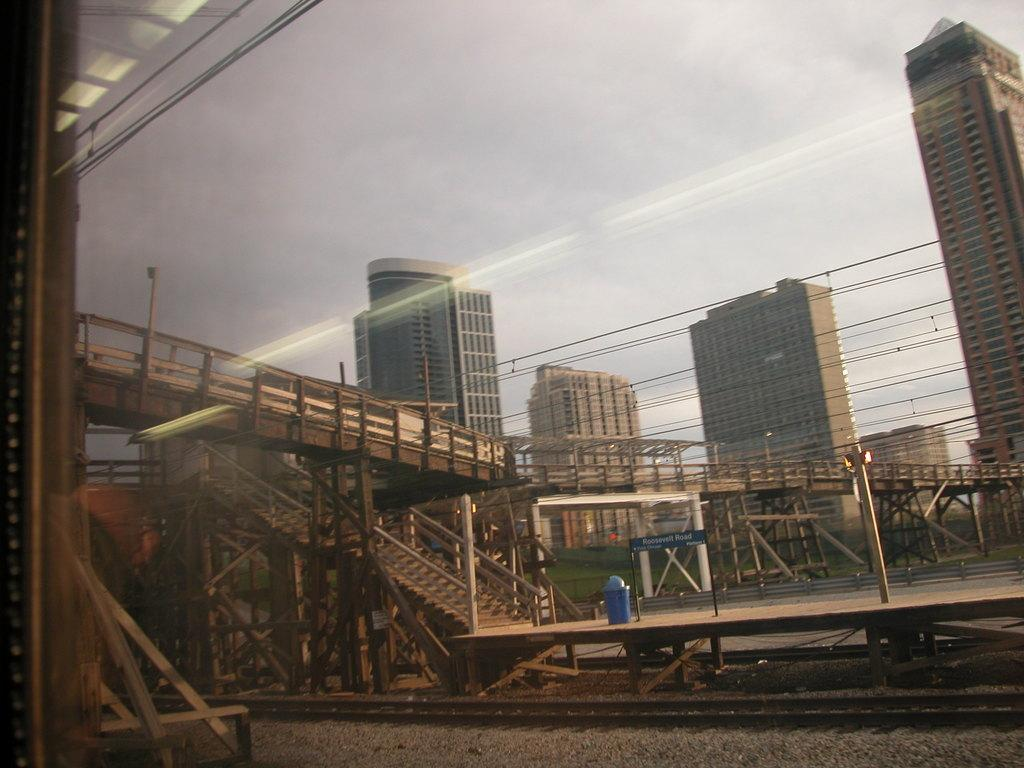What is located in the foreground of the image? There is a staircase, a stage, a railway track, stones, and a bridge in the foreground of the image. What can be seen in the center of the image? There are buildings and grass in the center of the image. How would you describe the sky in the image? The sky is cloudy in the image. How many cakes are being served on the gate in the image? There is no gate or cakes present in the image. What type of earth can be seen in the image? The image does not depict any earth or soil; it features a staircase, a stage, a railway track, stones, a bridge, buildings, grass, and a cloudy sky. 